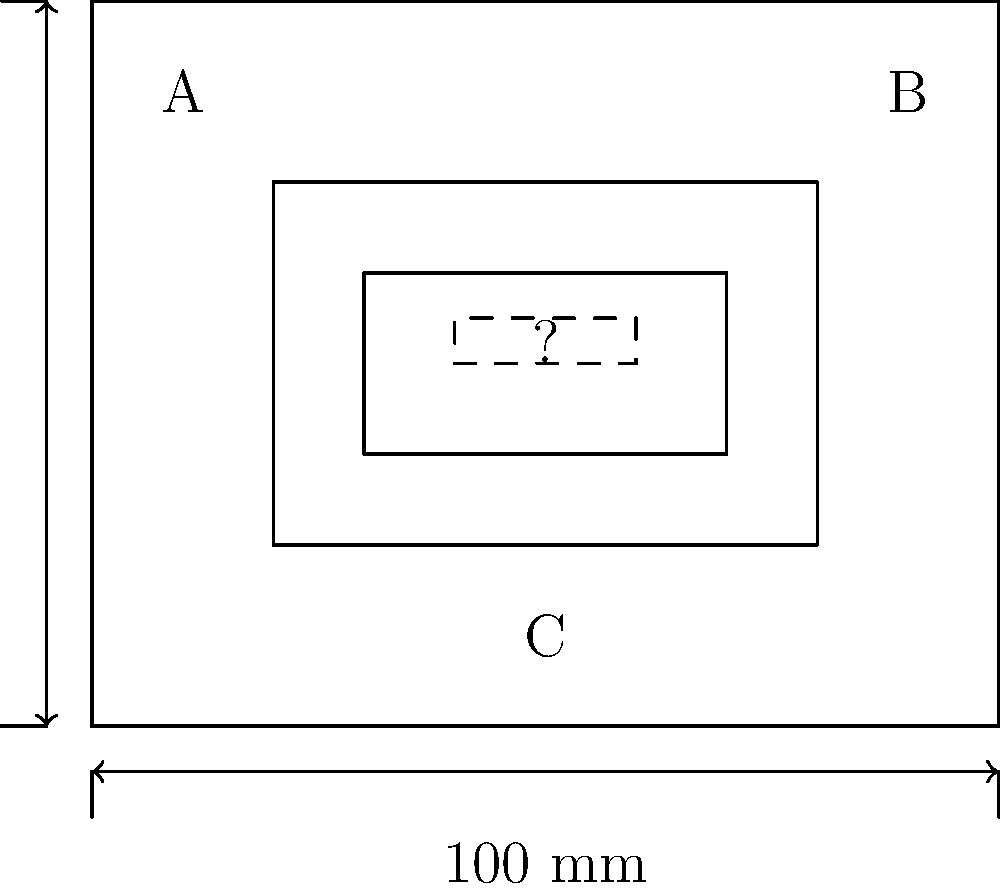The engineering blueprint above shows a design for a component with internal structures. Component A, B, and C are clearly labeled, but there appears to be a missing component marked with a "?". Based on the symmetry and layout of the design, what are the approximate dimensions (length x width) of the missing component? To determine the dimensions of the missing component, we need to analyze the blueprint systematically:

1. First, observe that the overall dimensions of the blueprint are 100 mm x 80 mm.

2. The outer rectangle (likely representing the main component casing) is slightly smaller, approximately 60 mm x 40 mm (from 20 mm to 80 mm horizontally, and from 20 mm to 60 mm vertically).

3. Inside this, there's another rectangle, approximately 40 mm x 20 mm (from 30 mm to 70 mm horizontally, and from 30 mm to 50 mm vertically).

4. The missing component is shown as a dashed rectangle in the center of this inner rectangle.

5. To estimate its size, we can see that it spans about half the width of the inner rectangle (40 mm / 2 = 20 mm).

6. For the height, it appears to be about 1/4 of the height of the inner rectangle (20 mm / 4 = 5 mm).

Therefore, the approximate dimensions of the missing component are 20 mm x 5 mm.
Answer: 20 mm x 5 mm 